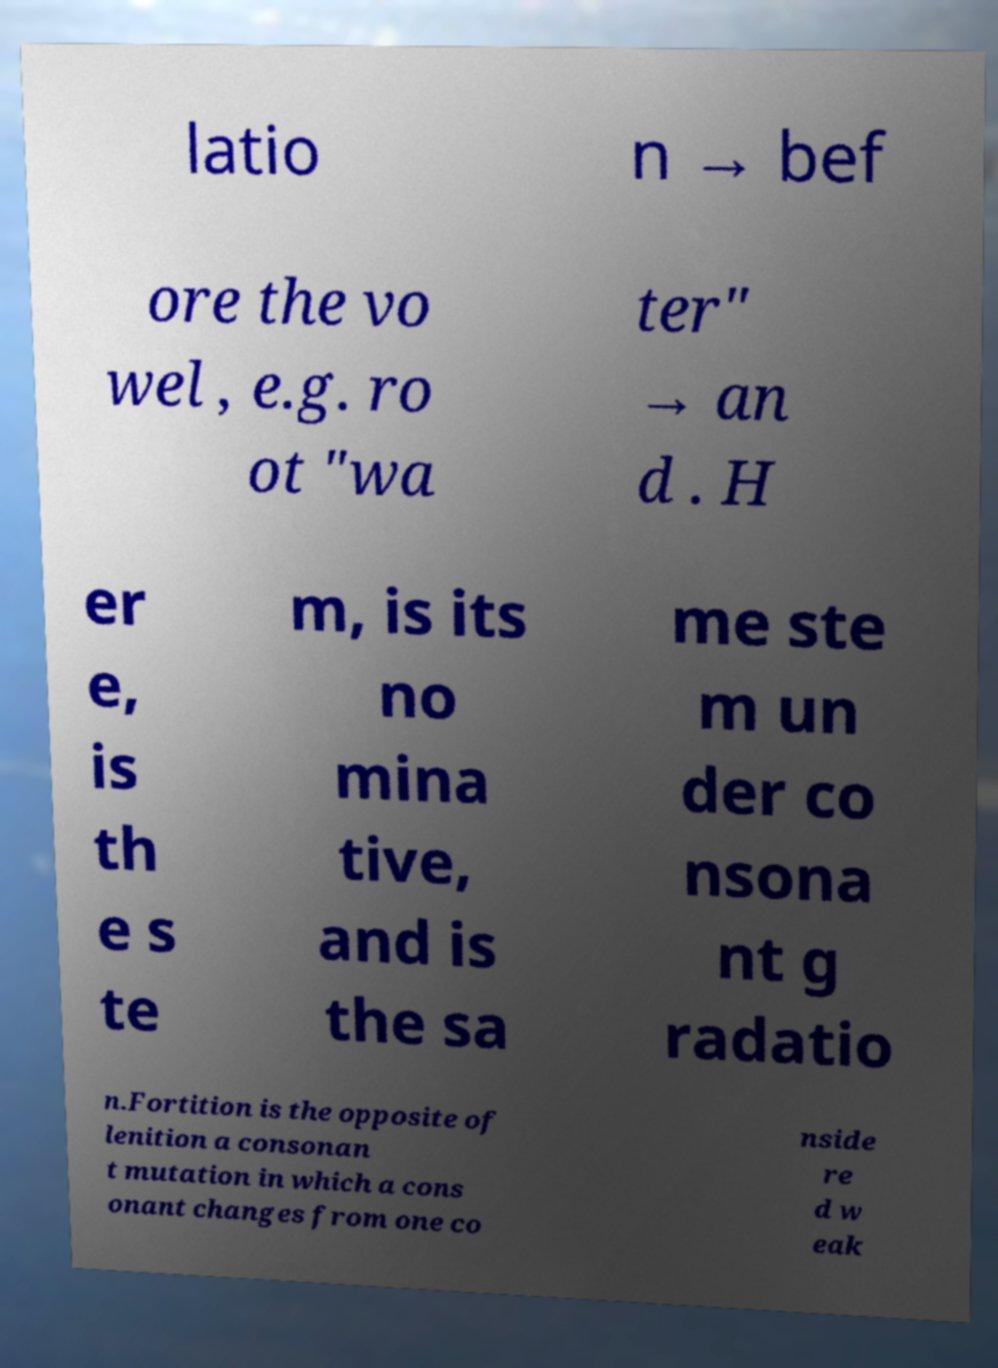What messages or text are displayed in this image? I need them in a readable, typed format. latio n → bef ore the vo wel , e.g. ro ot "wa ter" → an d . H er e, is th e s te m, is its no mina tive, and is the sa me ste m un der co nsona nt g radatio n.Fortition is the opposite of lenition a consonan t mutation in which a cons onant changes from one co nside re d w eak 